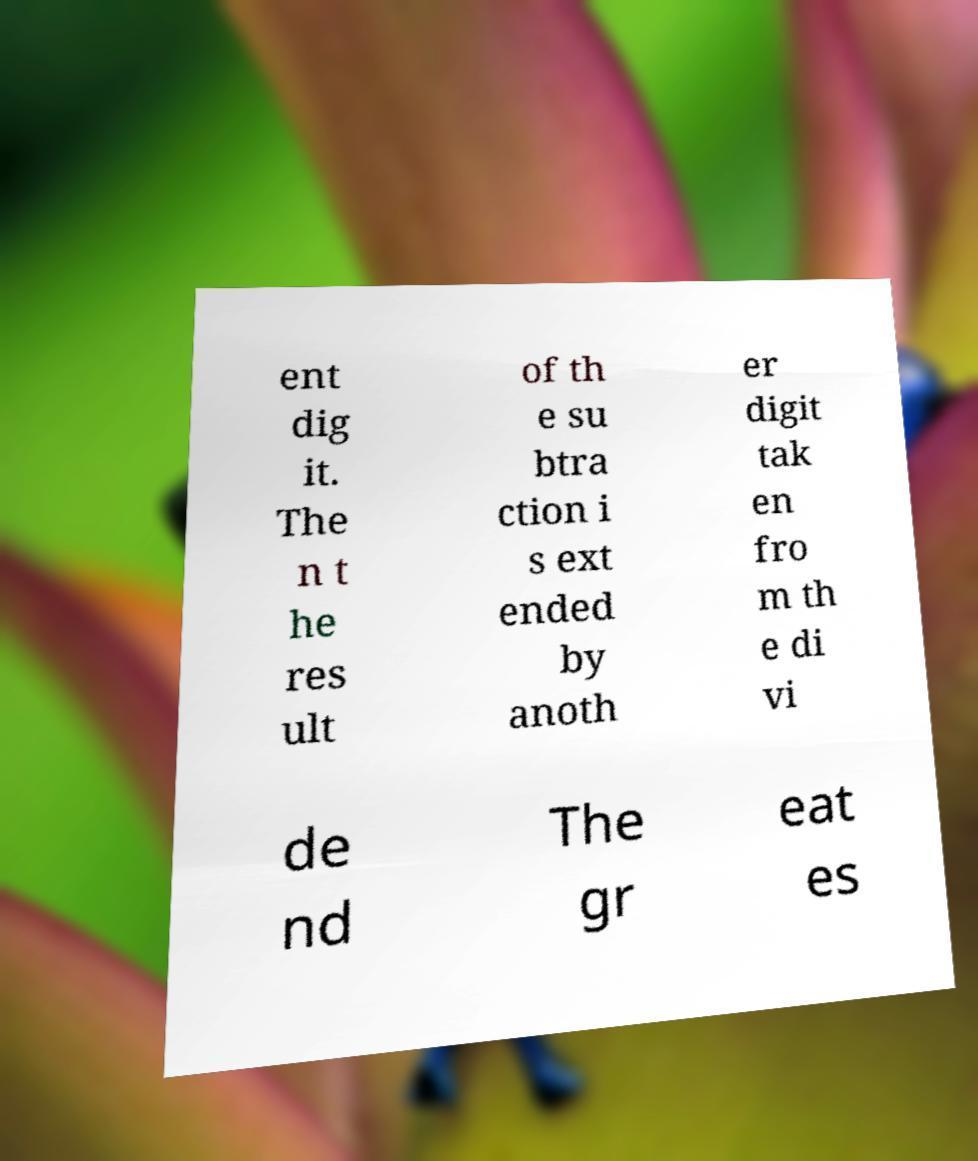Please identify and transcribe the text found in this image. ent dig it. The n t he res ult of th e su btra ction i s ext ended by anoth er digit tak en fro m th e di vi de nd The gr eat es 